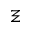<formula> <loc_0><loc_0><loc_500><loc_500>\Xi</formula> 